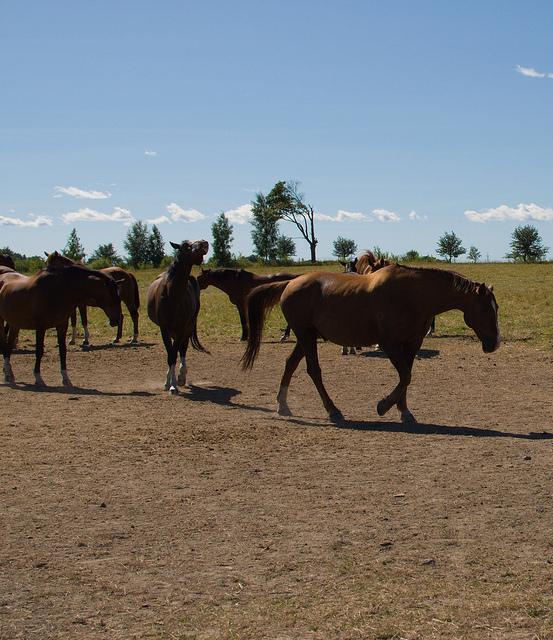This slowly moving horse is doing what?
Choose the right answer from the provided options to respond to the question.
Options: Standing, trotting, springing, sitting. Trotting. 